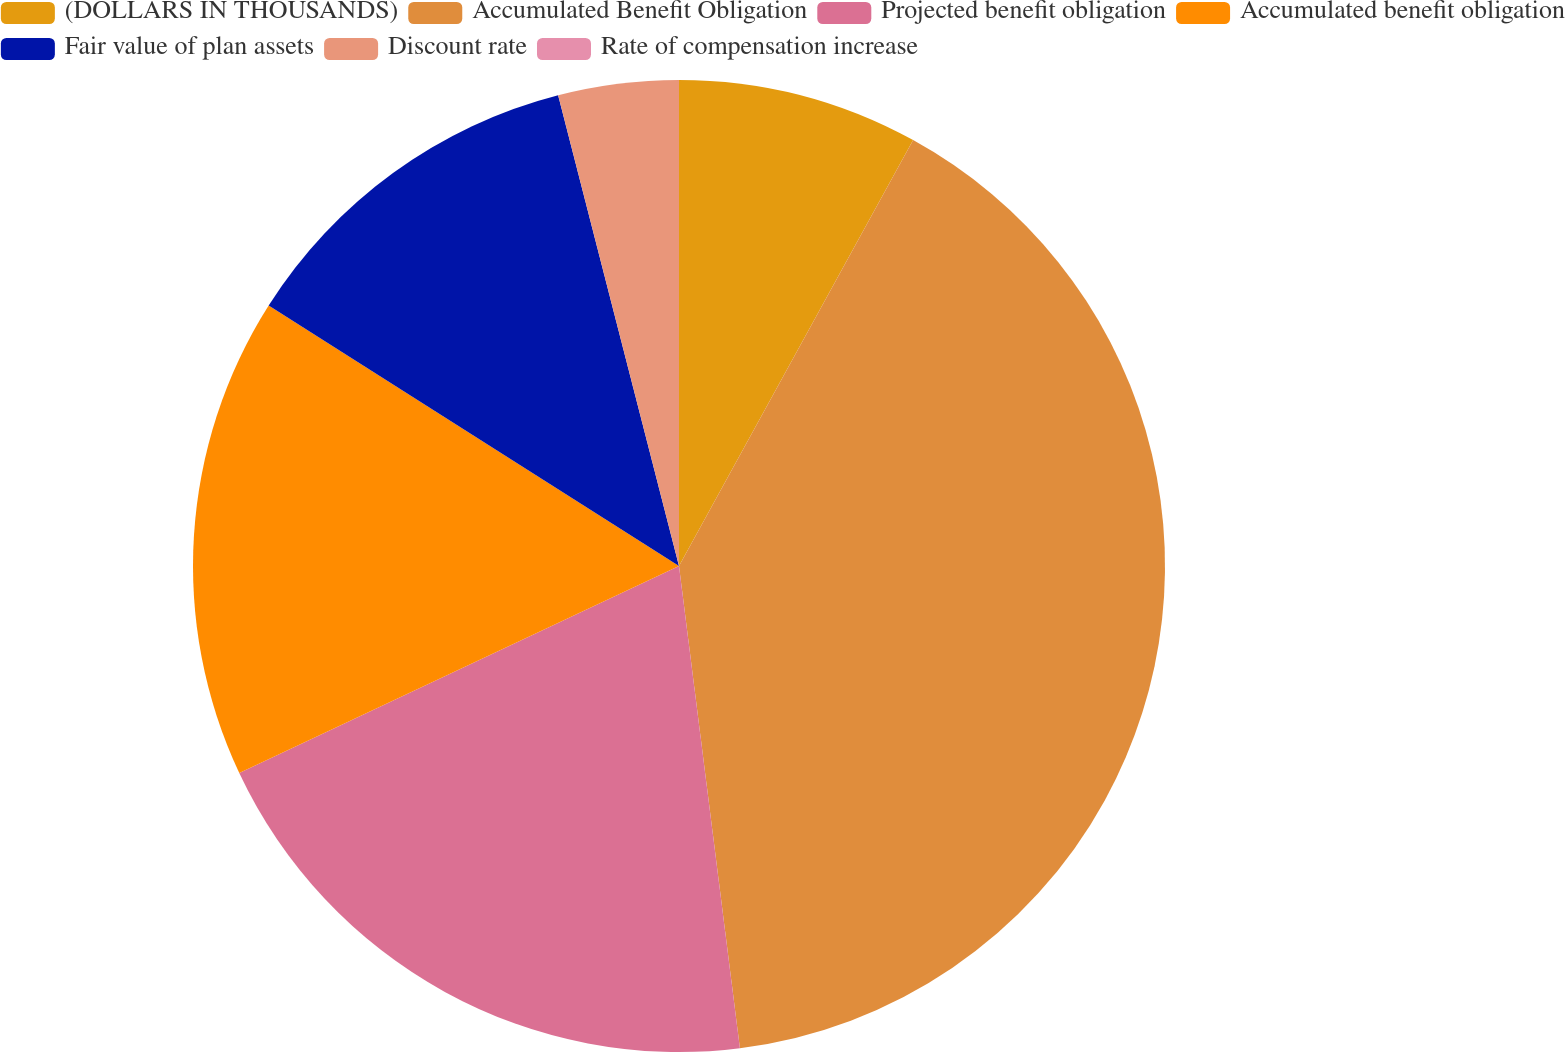Convert chart. <chart><loc_0><loc_0><loc_500><loc_500><pie_chart><fcel>(DOLLARS IN THOUSANDS)<fcel>Accumulated Benefit Obligation<fcel>Projected benefit obligation<fcel>Accumulated benefit obligation<fcel>Fair value of plan assets<fcel>Discount rate<fcel>Rate of compensation increase<nl><fcel>8.0%<fcel>40.0%<fcel>20.0%<fcel>16.0%<fcel>12.0%<fcel>4.0%<fcel>0.0%<nl></chart> 